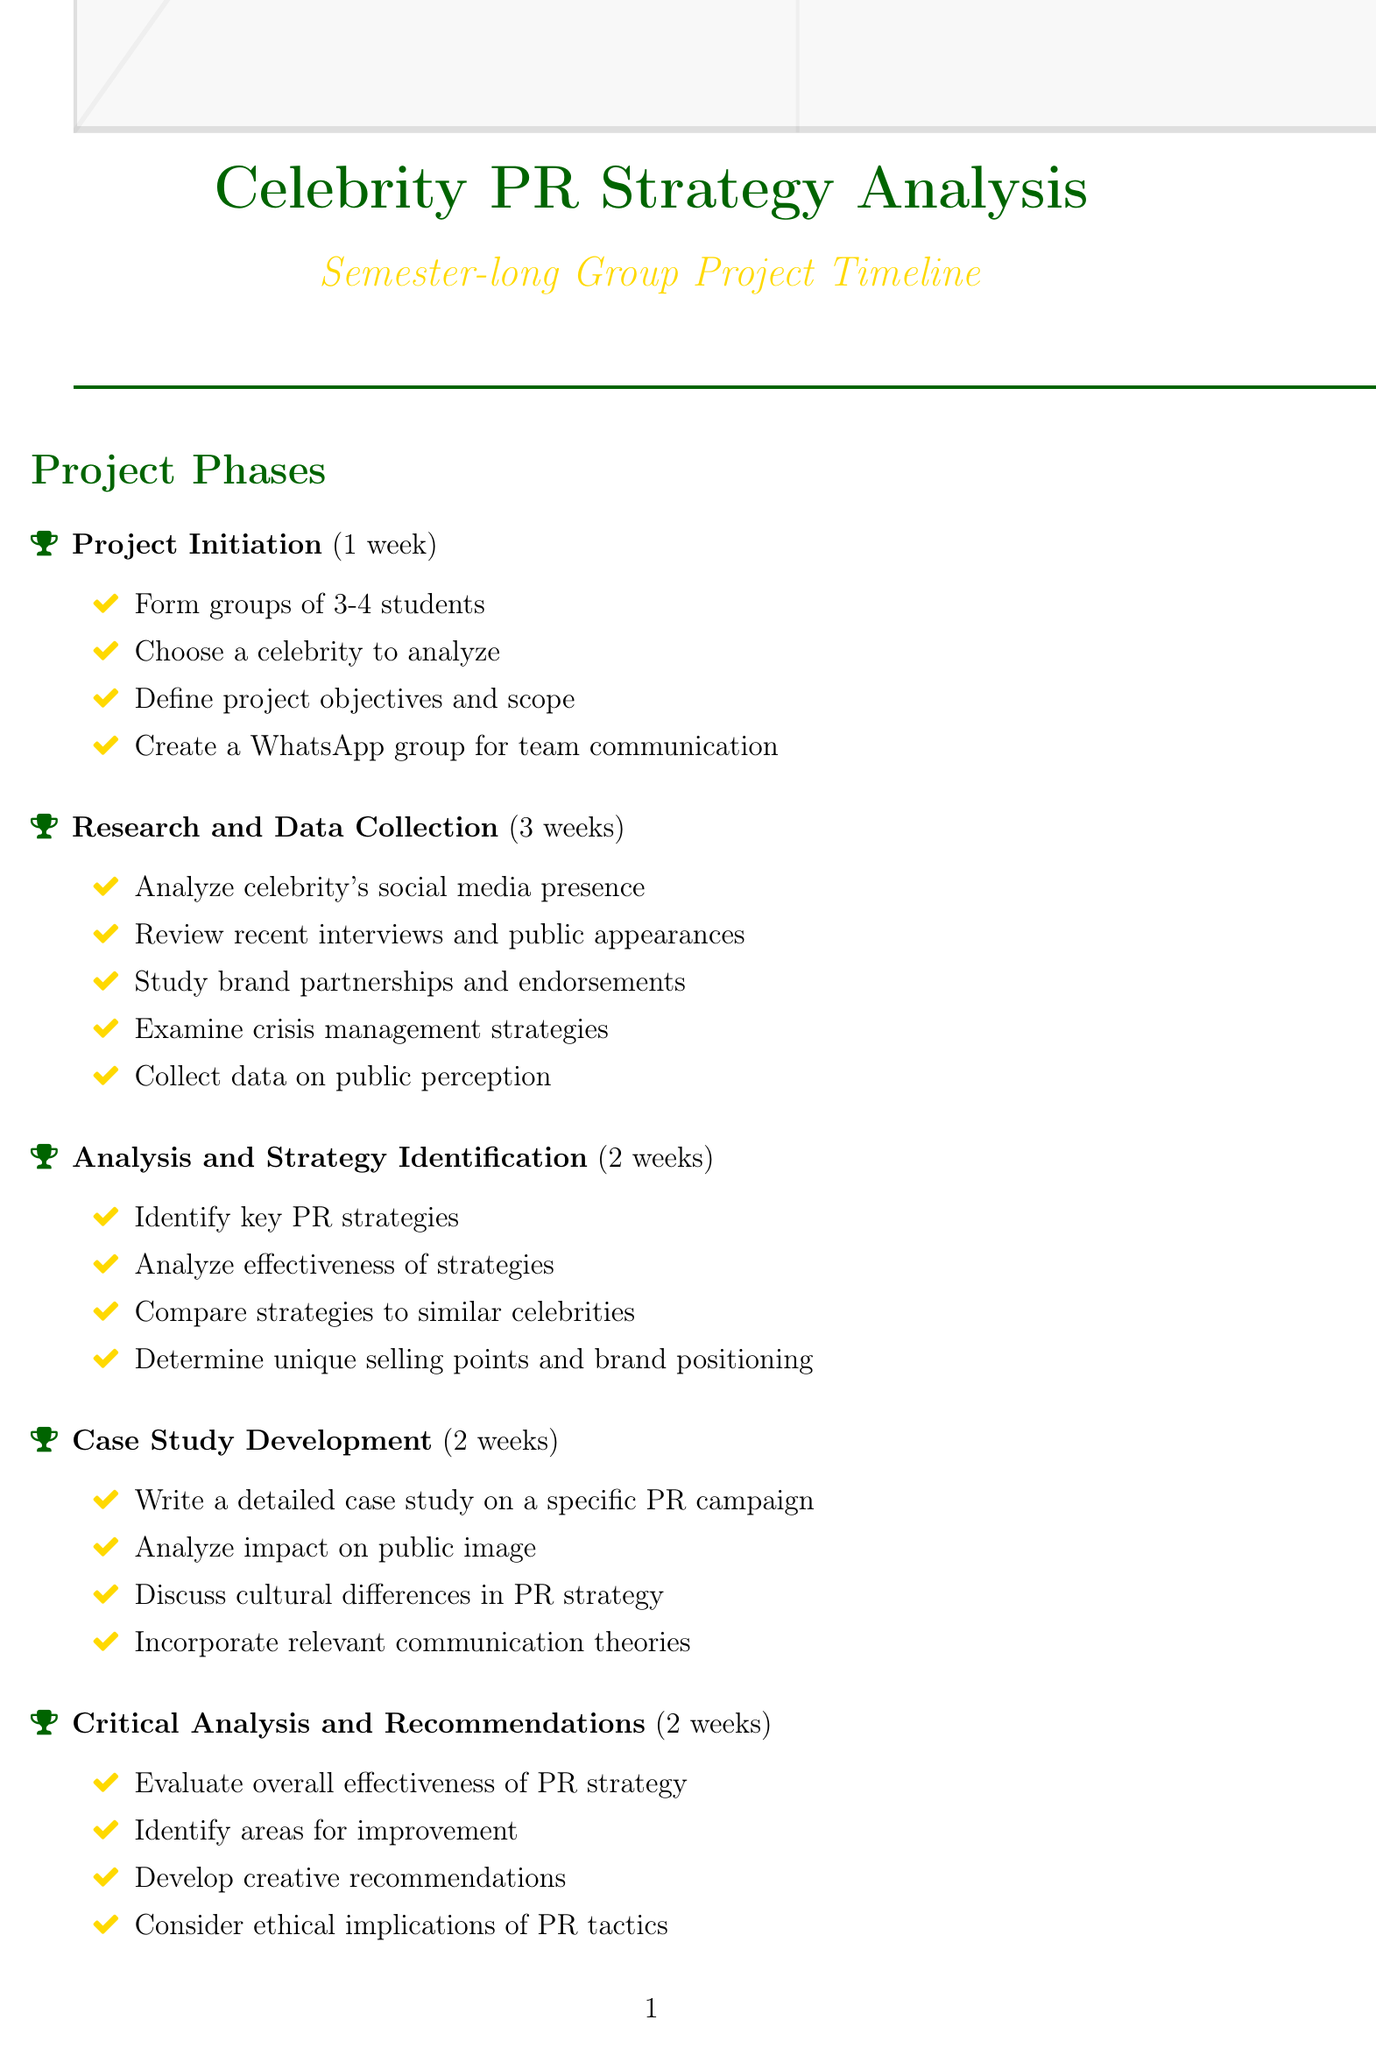What is the duration of the Project Initiation phase? The duration of the Project Initiation phase is stated in the document as 1 week.
Answer: 1 week How many weeks are allocated for Research and Data Collection? The document specifies that Research and Data Collection lasts for 3 weeks.
Answer: 3 weeks What is one of the tasks during the Case Study Development phase? The document lists writing a detailed case study on a specific PR campaign as a task during this phase.
Answer: Write a detailed case study on a specific PR campaign What resources are mentioned for social media analysis? The document indicates access to tools like Hootsuite or Sprout Social for this purpose.
Answer: Hootsuite or Sprout Social What is the main focus of the Critical Analysis and Recommendations phase? This phase focuses on evaluating the overall effectiveness of the celebrity's PR strategy.
Answer: Evaluate the overall effectiveness of the celebrity's PR strategy Which celebrity is an example given for analysis? The document gives Taylor Swift as one of the examples of celebrities to analyze.
Answer: Taylor Swift How many weeks are allocated for Presentation Preparation? The document specifies that Presentation Preparation takes 1 week.
Answer: 1 week What is required to be included in the final submission? The document states that submission of the final report and presentation slides is required.
Answer: Final report and presentation slides What is a criterion for evaluation mentioned in the document? The document includes depth of research and analysis as one of the evaluation criteria.
Answer: Depth of research and analysis Which celebrity is listed as a potential subject from Australia? The document lists Hugh Jackman as a potential celebrity to analyze.
Answer: Hugh Jackman 